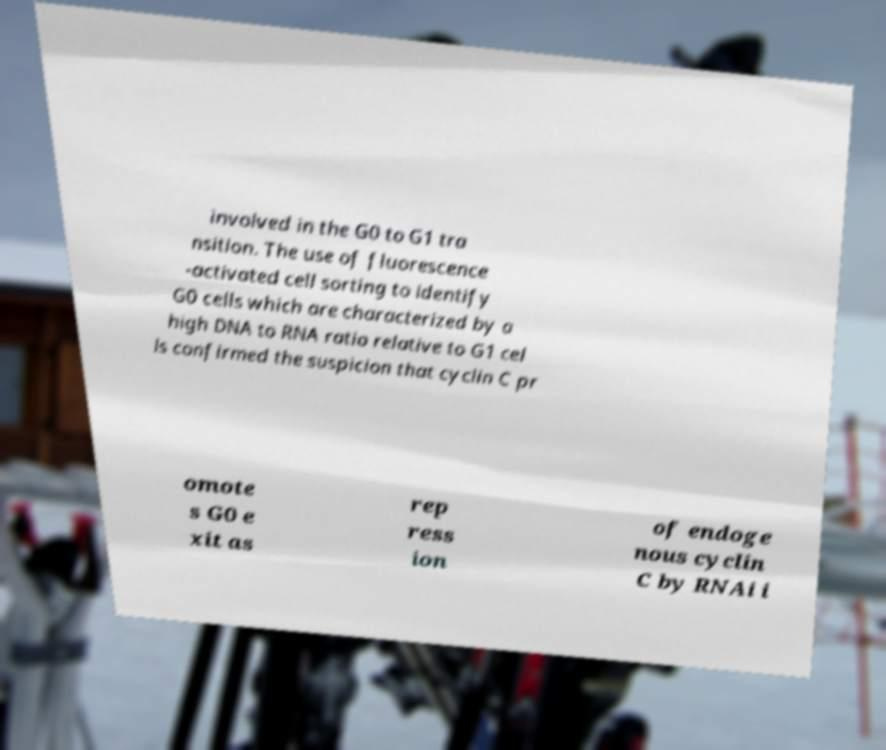I need the written content from this picture converted into text. Can you do that? involved in the G0 to G1 tra nsition. The use of fluorescence -activated cell sorting to identify G0 cells which are characterized by a high DNA to RNA ratio relative to G1 cel ls confirmed the suspicion that cyclin C pr omote s G0 e xit as rep ress ion of endoge nous cyclin C by RNAi i 